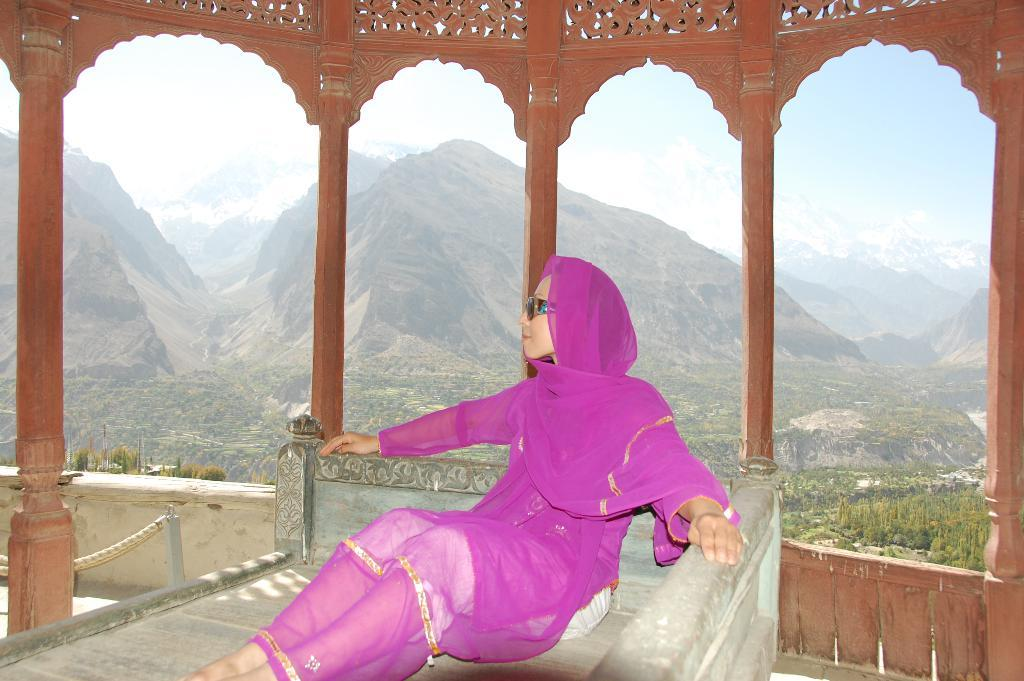What type of location is depicted in the image? The image shows an inside view of a building. Who is present in the image? There is a woman in the image. What is the woman wearing? The woman is wearing a pink dress. What is the woman doing in the image? The woman is sitting on a bed. What can be seen in the background of the image? There is a hill and the sky visible in the background of the image. What type of milk is the woman drinking in the image? There is no milk present in the image; the woman is sitting on a bed wearing a pink dress. 